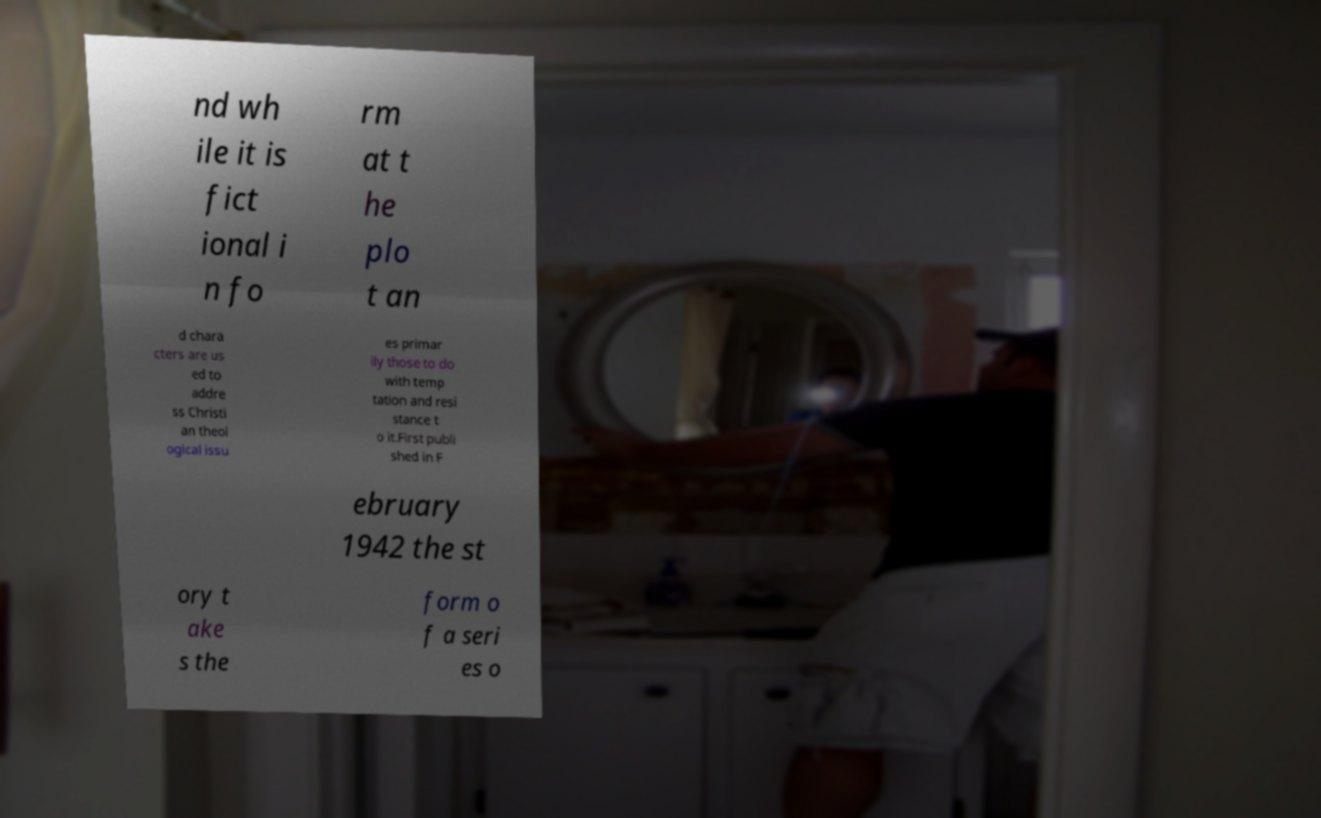Please identify and transcribe the text found in this image. nd wh ile it is fict ional i n fo rm at t he plo t an d chara cters are us ed to addre ss Christi an theol ogical issu es primar ily those to do with temp tation and resi stance t o it.First publi shed in F ebruary 1942 the st ory t ake s the form o f a seri es o 